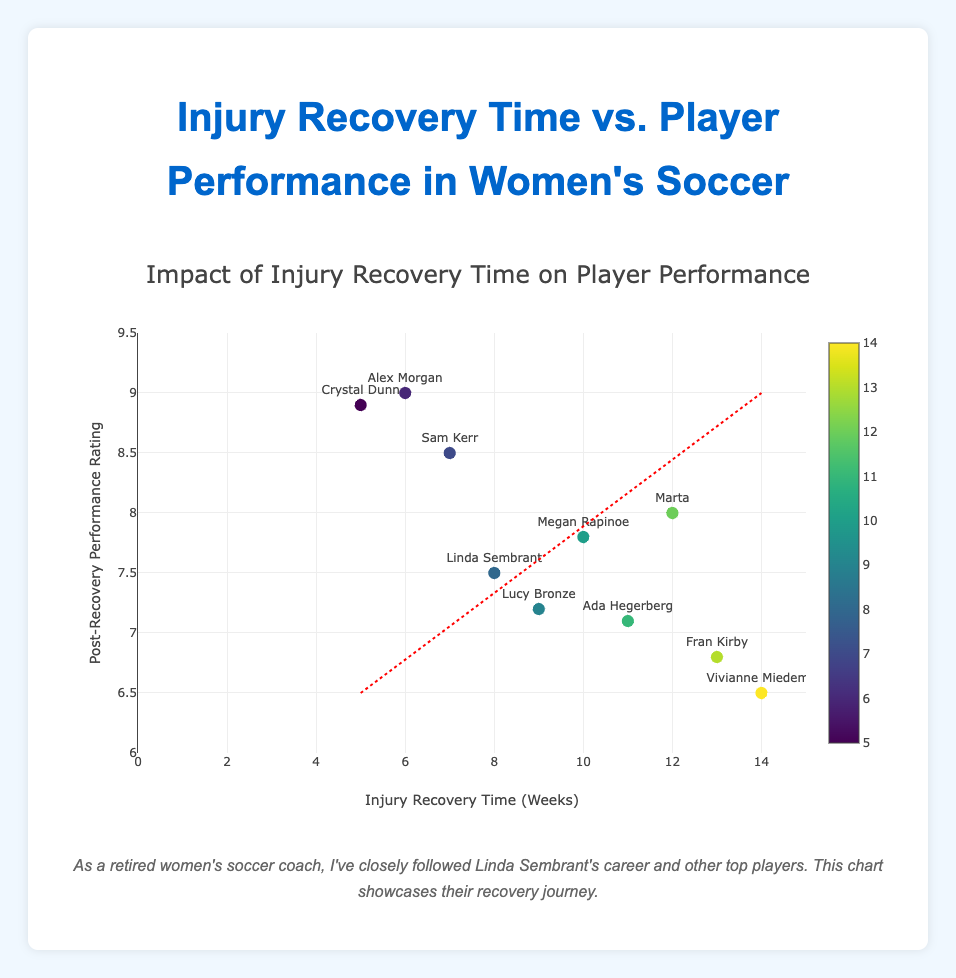What is the title of the figure? The title is usually displayed at the top of the figure and summarizes the main content. In this case, it should be easy to spot.
Answer: Injury Recovery Time vs. Player Performance in Women's Soccer How many data points are there in the figure? We count the number of individual markers representing data points for each player in the scatter plot. In this case, each player's data forms one point.
Answer: 10 Which player has the highest post-recovery performance rating? By examining the y-axis (Post-Recovery Performance Rating) and looking for the highest point, we can identify the player at that point.
Answer: Alex Morgan Which player had the longest injury recovery time? By examining the x-axis (Injury Recovery Time) and looking for the furthest point to the right, we can identify the player.
Answer: Vivianne Miedema What is the range of the post-recovery performance ratings? We determine the lowest and highest values on the y-axis. The lowest rating is 6.5 and the highest is 9.0. The range is the difference between these two values.
Answer: 2.5 (from 6.5 to 9.0) Which player had the shortest injury recovery time and what was their post-recovery performance rating? We'll look for the point closest to the origin on the x-axis for the shortest recovery time, then check the corresponding y-value for their performance rating.
Answer: Crystal Dunn; 8.9 Do players with shorter recovery times generally perform better post-recovery? We can observe the overall trend by examining the scatter plot and considering the trend line's direction. A negative trend line would indicate better performance with shorter recovery times.
Answer: Yes, generally What is the average injury recovery time? To compute the average recovery time, sum up all the injury recovery time values and divide by the number of players. Calculations: (8+12+10+6+14+9+7+5+11+13)/10 = 95/10 = 9.5
Answer: 9.5 weeks Which two players have similar injury recovery times but different performance ratings? Look for points with close x-values (recovery times), then compare their corresponding y-values (performance ratings). Sam Kerr (7 weeks, 8.5) and Linda Sembrant (8 weeks, 7.5) are close.
Answer: Sam Kerr and Linda Sembrant Is there a player with an above-average recovery time and above-average performance rating? First, find the average recovery time (9.5 weeks) and average performance rating (7.73). Then, identify which players are above both averages. Alex Morgan, who had a 6-week recovery time but a high performance rating.
Answer: Alex Morgan 